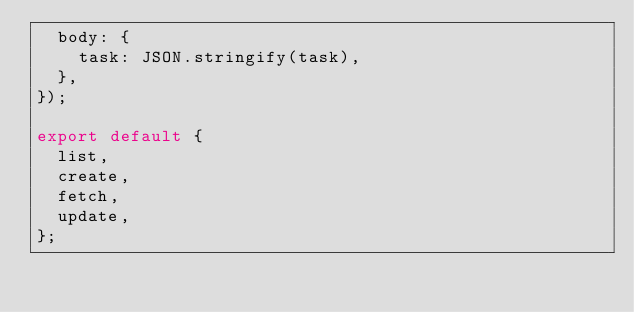<code> <loc_0><loc_0><loc_500><loc_500><_JavaScript_>  body: {
    task: JSON.stringify(task),
  },
});

export default {
  list,
  create,
  fetch,
  update,
};
</code> 